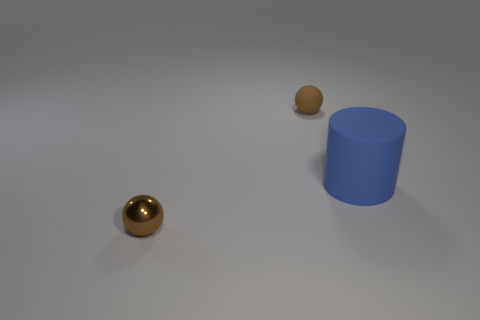Add 3 matte cylinders. How many objects exist? 6 Subtract all cylinders. How many objects are left? 2 Add 1 large red metallic blocks. How many large red metallic blocks exist? 1 Subtract 0 brown cylinders. How many objects are left? 3 Subtract all tiny purple rubber cylinders. Subtract all tiny shiny spheres. How many objects are left? 2 Add 3 brown shiny balls. How many brown shiny balls are left? 4 